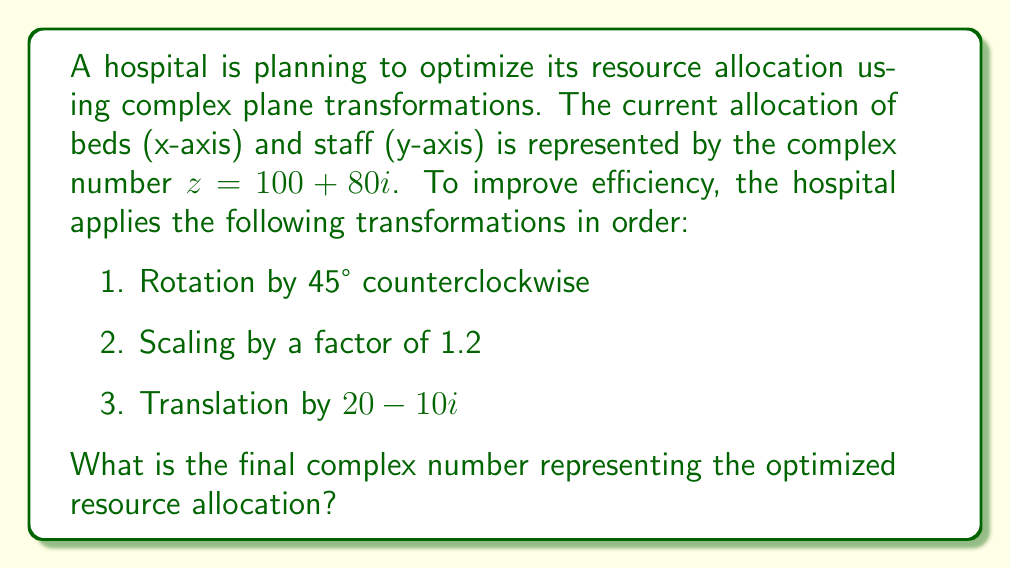Provide a solution to this math problem. Let's approach this step-by-step:

1. Rotation by 45° counterclockwise:
   The formula for rotation is $z' = z \cdot (\cos\theta + i\sin\theta)$
   For 45°, $\cos45° = \sin45° = \frac{1}{\sqrt{2}}$
   $$z_1 = (100 + 80i) \cdot (\frac{1}{\sqrt{2}} + i\frac{1}{\sqrt{2}})$$
   $$z_1 = \frac{100 + 80i + 100i - 80}{\sqrt{2}} = \frac{20 + 180i}{\sqrt{2}}$$
   $$z_1 = 10\sqrt{2} + 90\sqrt{2}i$$

2. Scaling by a factor of 1.2:
   Multiply the result by 1.2
   $$z_2 = 1.2 \cdot (10\sqrt{2} + 90\sqrt{2}i)$$
   $$z_2 = 12\sqrt{2} + 108\sqrt{2}i$$

3. Translation by $20 - 10i$:
   Add $20 - 10i$ to the result
   $$z_3 = (12\sqrt{2} + 108\sqrt{2}i) + (20 - 10i)$$
   $$z_3 = (12\sqrt{2} + 20) + (108\sqrt{2} - 10)i$$

To simplify:
$$z_3 \approx 36.97 + 142.71i$$
Answer: $36.97 + 142.71i$ 